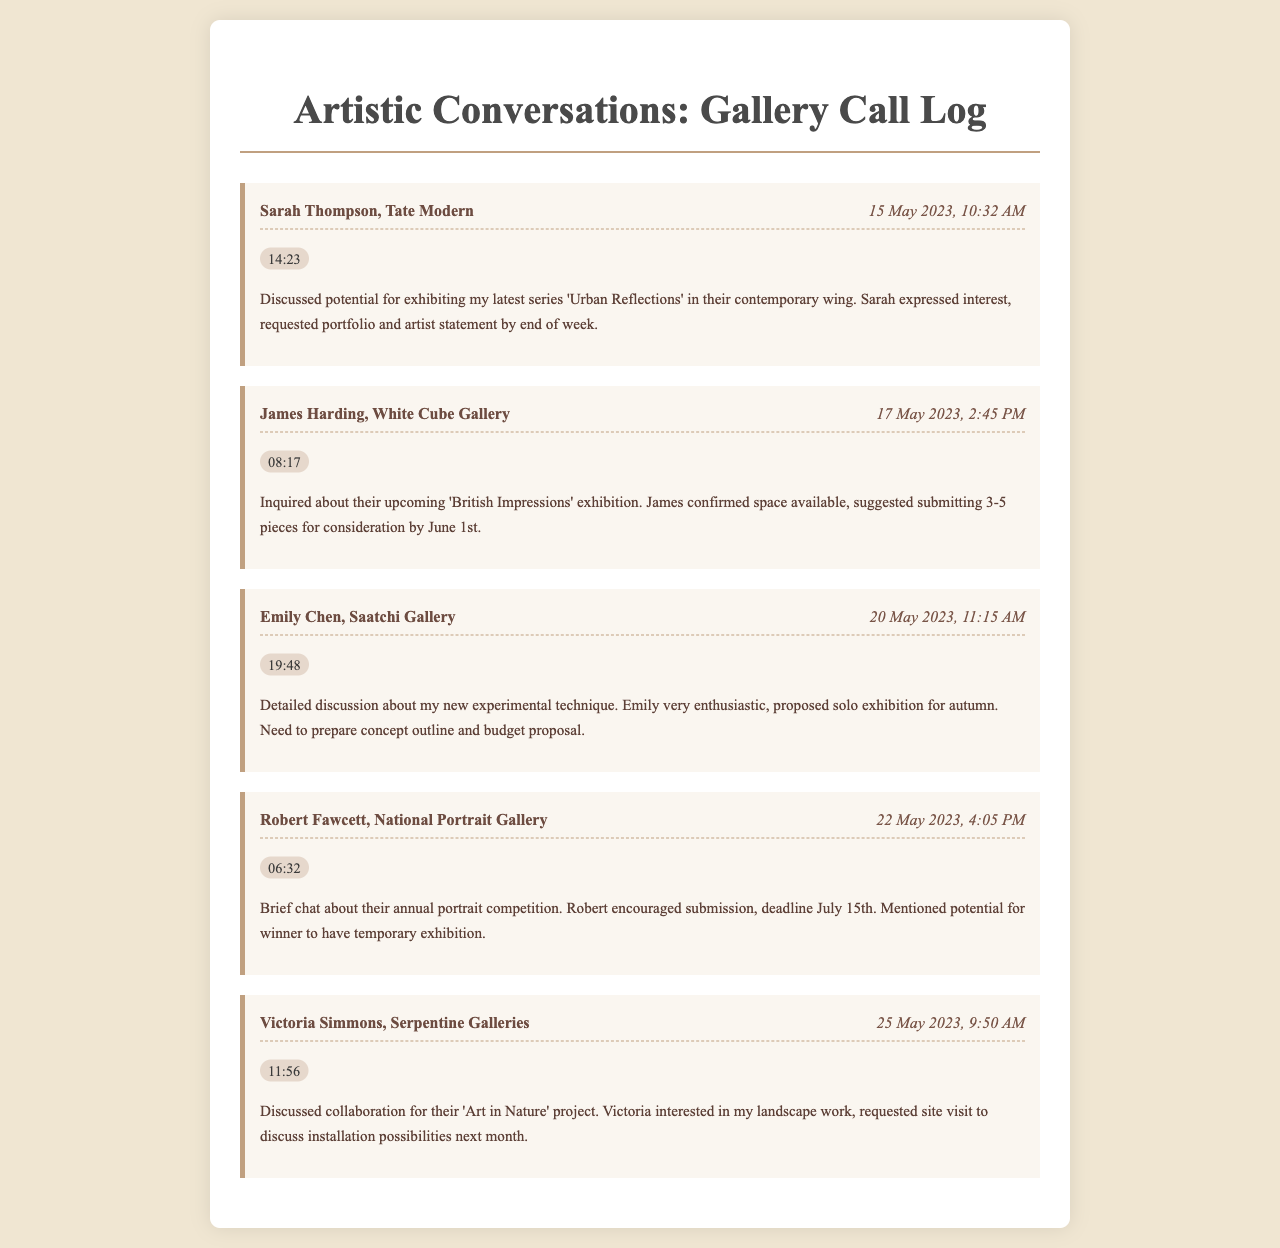what is the name of the gallery discussed in the call with Sarah Thompson? Sarah Thompson is associated with Tate Modern, as indicated in the call log.
Answer: Tate Modern what is the date of the call with James Harding? The call with James Harding took place on 17 May 2023, which is specifically noted in the document.
Answer: 17 May 2023 how long did the conversation with Emily Chen last? The duration of the call with Emily Chen was 19 minutes and 48 seconds, as documented.
Answer: 19:48 what is the title of the upcoming exhibition mentioned by James Harding? James Harding mentioned the 'British Impressions' exhibition during the call.
Answer: British Impressions who showed interest in my landscape work? Victoria Simmons expressed interest in the landscape work during the discussion about their project.
Answer: Victoria Simmons what deadline is mentioned for the portrait competition? The deadline for the portrait competition is noted as July 15th in the conversation with Robert Fawcett.
Answer: July 15th how many pieces did James suggest submitting for the exhibition? James suggested submitting 3-5 pieces for consideration.
Answer: 3-5 pieces what is the purpose of the call with Victoria Simmons? The call with Victoria Simmons was to discuss a collaboration for their 'Art in Nature' project.
Answer: collaboration for 'Art in Nature' when is the proposed solo exhibition by Emily scheduled for? The solo exhibition proposed by Emily is scheduled for autumn, as stated in the call notes.
Answer: autumn 